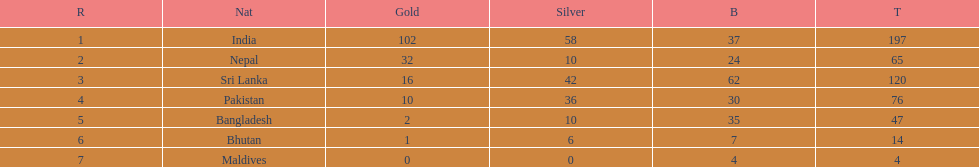Name a country listed in the table, other than india? Nepal. 